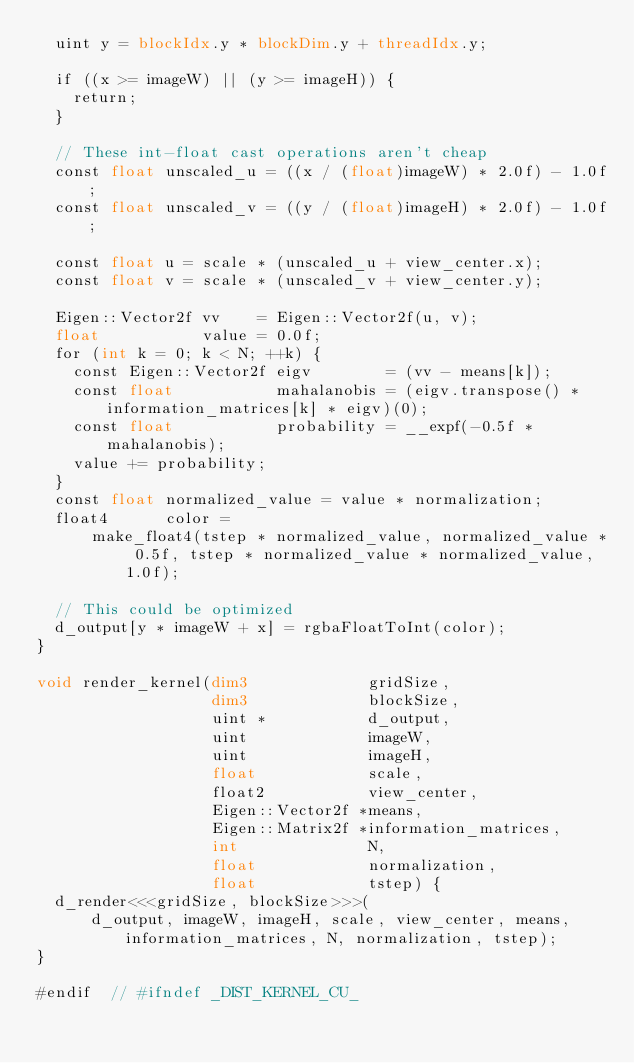<code> <loc_0><loc_0><loc_500><loc_500><_Cuda_>  uint y = blockIdx.y * blockDim.y + threadIdx.y;

  if ((x >= imageW) || (y >= imageH)) {
    return;
  }

  // These int-float cast operations aren't cheap
  const float unscaled_u = ((x / (float)imageW) * 2.0f) - 1.0f;
  const float unscaled_v = ((y / (float)imageH) * 2.0f) - 1.0f;

  const float u = scale * (unscaled_u + view_center.x);
  const float v = scale * (unscaled_v + view_center.y);

  Eigen::Vector2f vv    = Eigen::Vector2f(u, v);
  float           value = 0.0f;
  for (int k = 0; k < N; ++k) {
    const Eigen::Vector2f eigv        = (vv - means[k]);
    const float           mahalanobis = (eigv.transpose() * information_matrices[k] * eigv)(0);
    const float           probability = __expf(-0.5f * mahalanobis);
    value += probability;
  }
  const float normalized_value = value * normalization;
  float4      color =
      make_float4(tstep * normalized_value, normalized_value * 0.5f, tstep * normalized_value * normalized_value, 1.0f);

  // This could be optimized
  d_output[y * imageW + x] = rgbaFloatToInt(color);
}

void render_kernel(dim3             gridSize,
                   dim3             blockSize,
                   uint *           d_output,
                   uint             imageW,
                   uint             imageH,
                   float            scale,
                   float2           view_center,
                   Eigen::Vector2f *means,
                   Eigen::Matrix2f *information_matrices,
                   int              N,
                   float            normalization,
                   float            tstep) {
  d_render<<<gridSize, blockSize>>>(
      d_output, imageW, imageH, scale, view_center, means, information_matrices, N, normalization, tstep);
}

#endif  // #ifndef _DIST_KERNEL_CU_
</code> 